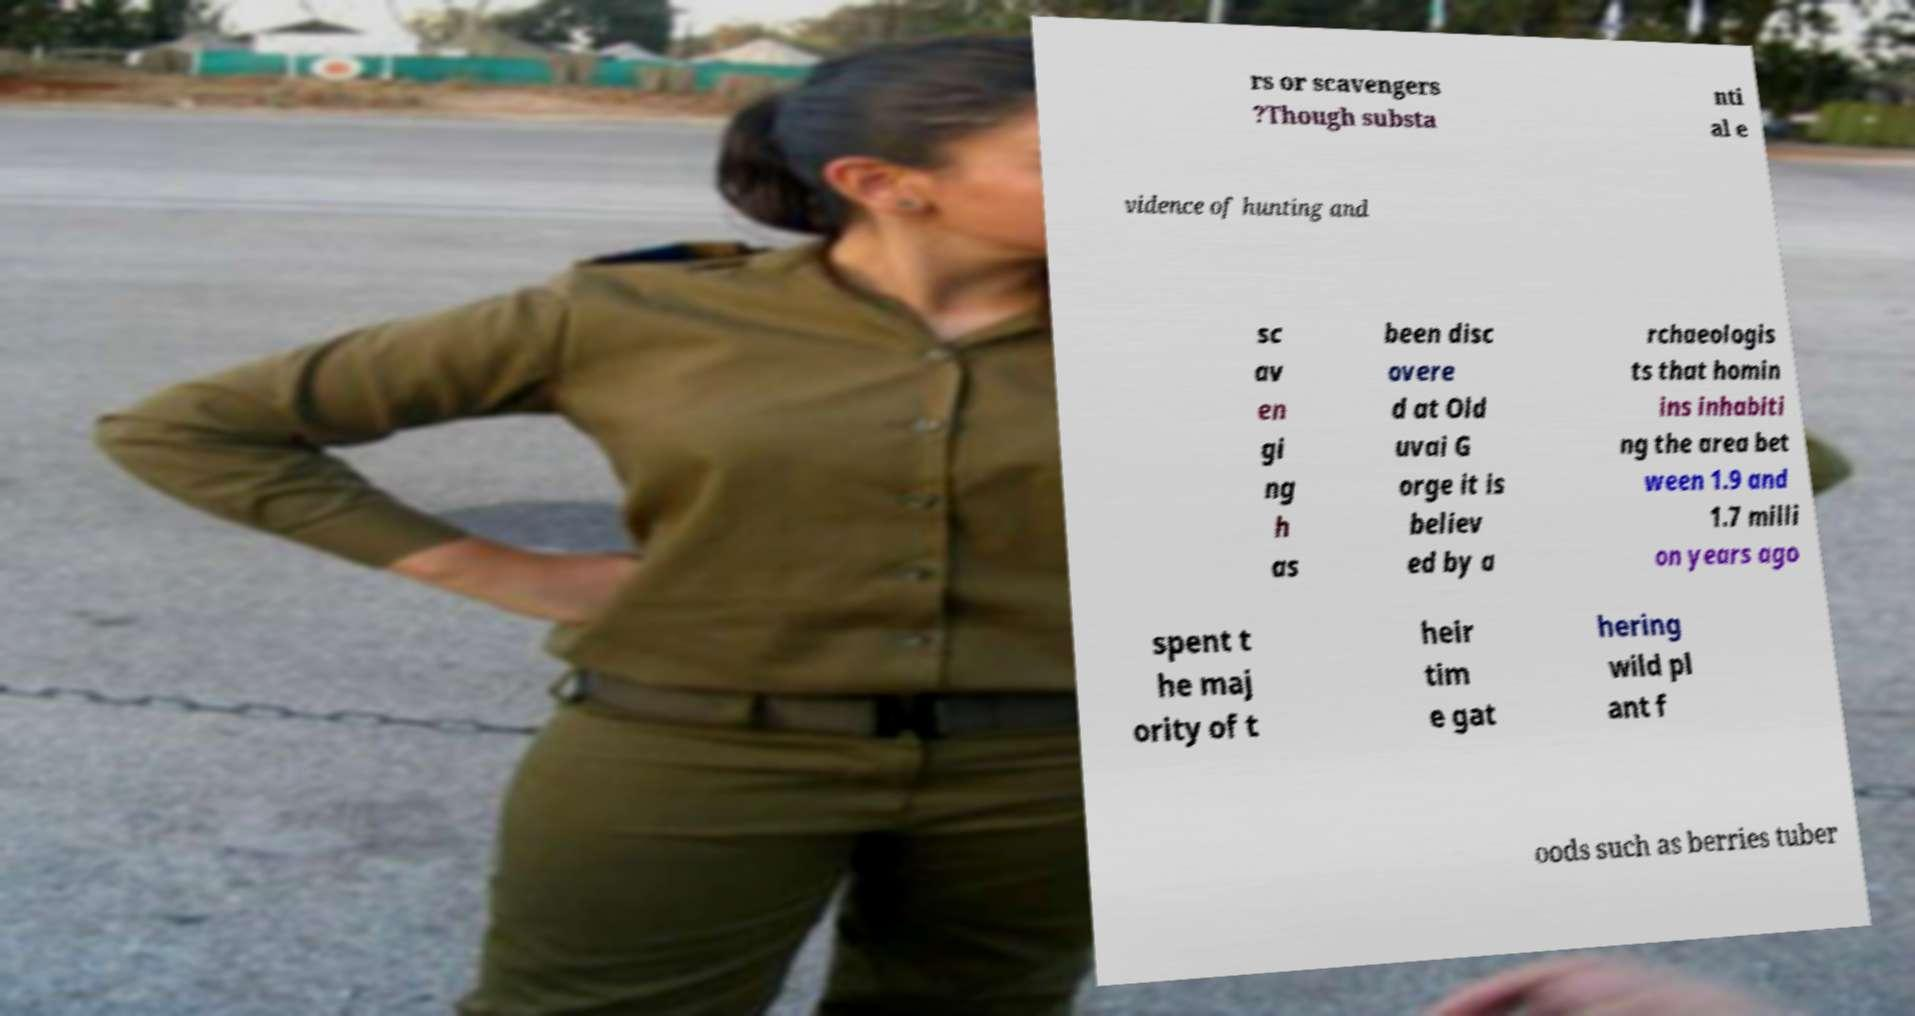Can you read and provide the text displayed in the image?This photo seems to have some interesting text. Can you extract and type it out for me? rs or scavengers ?Though substa nti al e vidence of hunting and sc av en gi ng h as been disc overe d at Old uvai G orge it is believ ed by a rchaeologis ts that homin ins inhabiti ng the area bet ween 1.9 and 1.7 milli on years ago spent t he maj ority of t heir tim e gat hering wild pl ant f oods such as berries tuber 